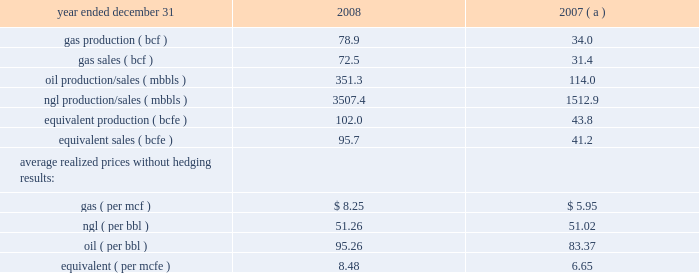Item 7 .
Management 2019s discussion and analysis of financial condition and results of operations results of operations 2013 highmount 2013 ( continued ) highmount 2019s revenues , profitability and future growth depend substantially on natural gas and ngl prices and highmount 2019s ability to increase its natural gas and ngl production .
In recent years , there has been significant price volatility in natural gas and ngl prices due to a variety of factors highmount cannot control or predict .
These factors , which include weather conditions , political and economic events , and competition from other energy sources , impact supply and demand for natural gas , which determines the pricing .
In recent months , natural gas prices decreased significantly due largely to increased onshore natural gas production , plentiful levels of working gas in storage and reduced commercial demand .
The increase in the onshore natural gas production was due largely to increased production from 201cunconventional 201d sources of natural gas such as shale gas , coalbed methane , tight sandstones and methane hydrates , made possible in recent years by modern technology in creating extensive artificial fractures around well bores and advances in horizontal drilling technology .
Other key factors contributing to the softness of natural gas prices likely included a lower level of industrial demand for natural gas , as a result of the ongoing economic downturn , and relatively low crude oil prices .
Due to industry conditions , in february of 2009 highmount elected to terminate contracts for five drilling rigs at its permian basin property in the sonora , texas area .
The estimated fee payable to the rig contractor for exercising this early termination right will be approximately $ 23 million .
In light of these developments , highmount will reduce 2009 production volumes through decreased drilling activity .
In addition , the price highmount realizes for its gas production is affected by highmount 2019s hedging activities as well as locational differences in market prices .
Highmount 2019s decision to increase its natural gas production is dependent upon highmount 2019s ability to realize attractive returns on its capital investment program .
Returns are affected by commodity prices , capital and operating costs .
Highmount 2019s operating income , which represents revenues less operating expenses , is primarily affected by revenue factors , but is also a function of varying levels of production expenses , production and ad valorem taxes , as well as depreciation , depletion and amortization ( 201cdd&a 201d ) expenses .
Highmount 2019s production expenses represent all costs incurred to operate and maintain wells and related equipment and facilities .
The principal components of highmount 2019s production expenses are , among other things , direct and indirect costs of labor and benefits , repairs and maintenance , materials , supplies and fuel .
In general , during 2008 highmount 2019s labor costs increased primarily due to higher salary levels and continued upward pressure on salaries and wages as a result of the increased competition for skilled workers .
In response to these market conditions , in 2008 highmount implemented retention programs , including increases in compensation .
Production expenses during 2008 were also affected by increases in the cost of fuel , materials and supplies .
The higher cost environment discussed above continued during all of 2008 .
During the fourth quarter of 2008 the price of natural gas declined significantly while operating expenses remained high .
This environment of low commodity prices and high operating expenses continued until december of 2008 when highmount began to see evidence of decreasing operating expenses and drilling costs .
Highmount 2019s production and ad valorem taxes increase primarily when prices of natural gas and ngls increase , but they are also affected by changes in production , as well as appreciated property values .
Highmount calculates depletion using the units-of-production method , which depletes the capitalized costs and future development costs associated with evaluated properties based on the ratio of production volumes for the current period to total remaining reserve volumes for the evaluated properties .
Highmount 2019s depletion expense is affected by its capital spending program and projected future development costs , as well as reserve changes resulting from drilling programs , well performance , and revisions due to changing commodity prices .
Presented below are production and sales statistics related to highmount 2019s operations: .

If 2009 gas production increases at the same rate as 2008 , what would the approximate 2009 product be , in bcf? 
Computations: ((78.9 / 34.0) * 78.9)
Answer: 183.09441. 